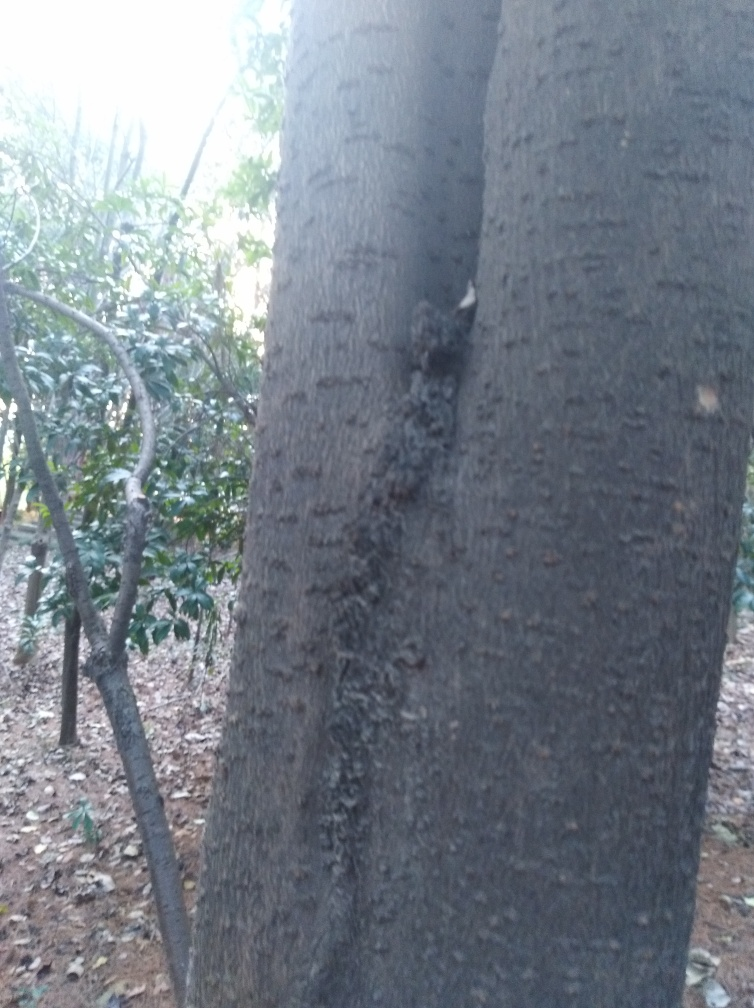Is there any wildlife or signs of animals in this picture? From what we can see, there do not appear to be any animals or obvious signs of wildlife in this particular snapshot of the environment. However, the texture of the bark and the natural surroundings could potentially be a habitat for various species. 